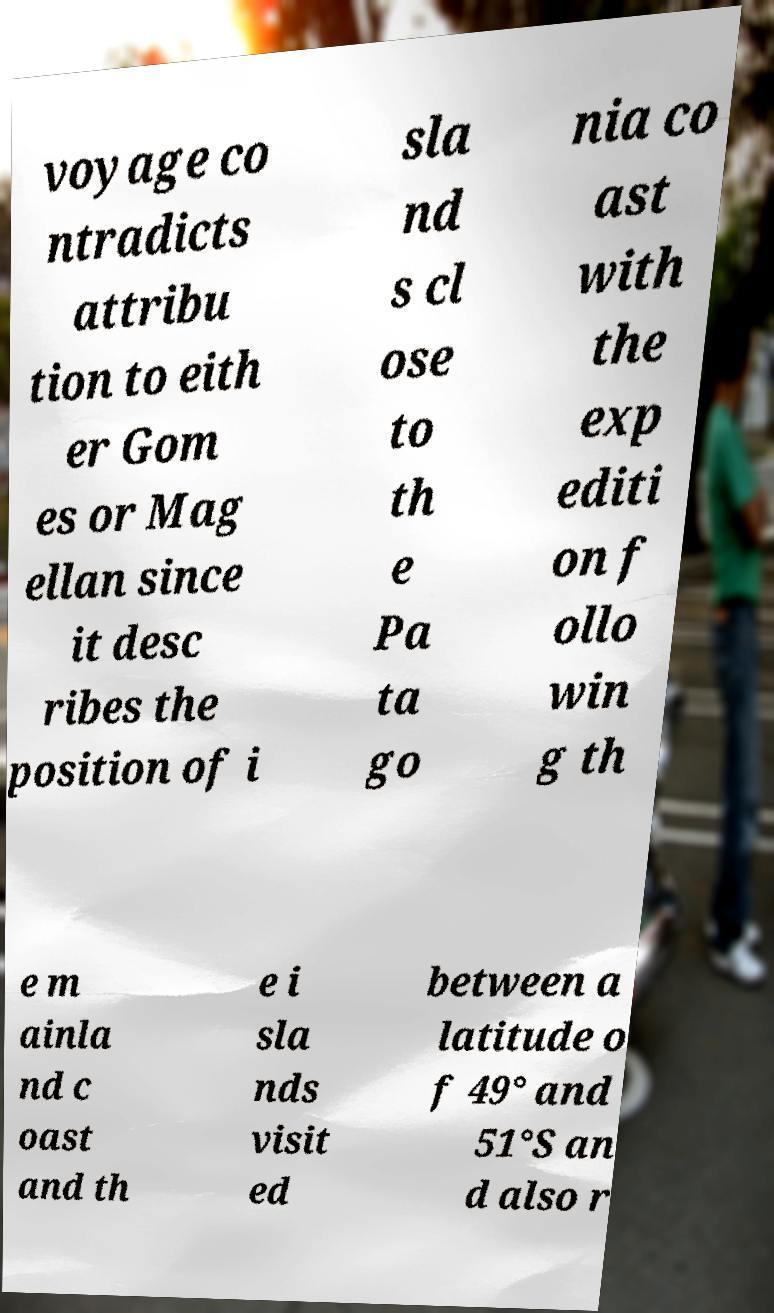What messages or text are displayed in this image? I need them in a readable, typed format. voyage co ntradicts attribu tion to eith er Gom es or Mag ellan since it desc ribes the position of i sla nd s cl ose to th e Pa ta go nia co ast with the exp editi on f ollo win g th e m ainla nd c oast and th e i sla nds visit ed between a latitude o f 49° and 51°S an d also r 